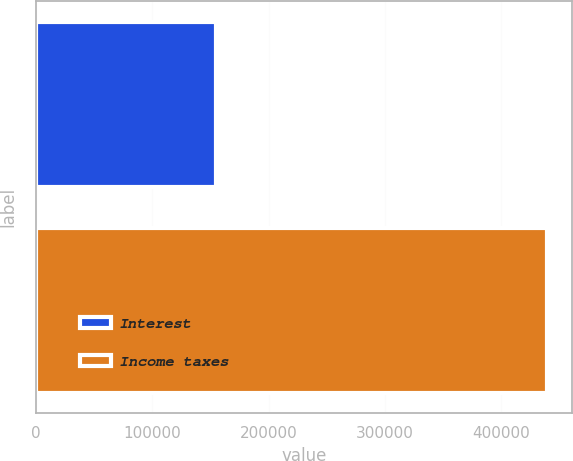<chart> <loc_0><loc_0><loc_500><loc_500><bar_chart><fcel>Interest<fcel>Income taxes<nl><fcel>154310<fcel>438840<nl></chart> 